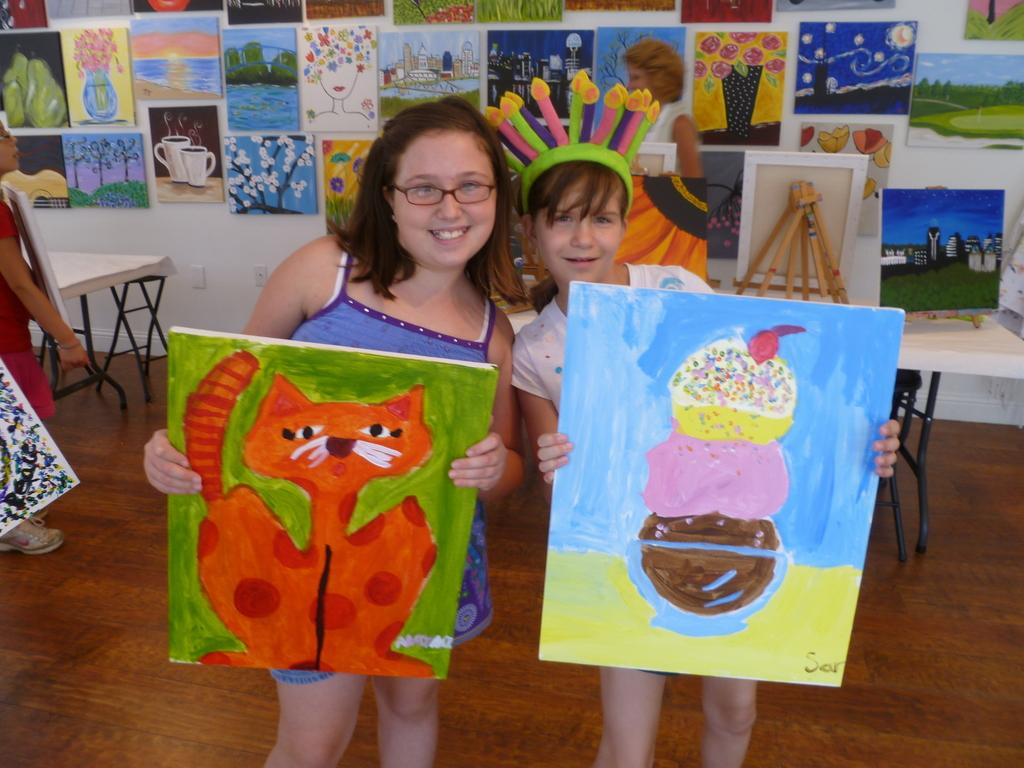How many kids are in the picture? There are two kids in the picture. What are the kids holding in the picture? The kids are holding paintings. Can you describe the paintings that the kids are holding? One painting depicts a cat, and the other painting depicts ice cream. What can be seen on the background wall in the picture? There are many paintings on the background wall. What type of science experiment is being conducted in the picture? There is no science experiment present in the image; it features two kids holding paintings. Can you tell me how many basins are visible in the picture? There are no basins visible in the picture; it shows two kids holding paintings and a background wall with many paintings. 